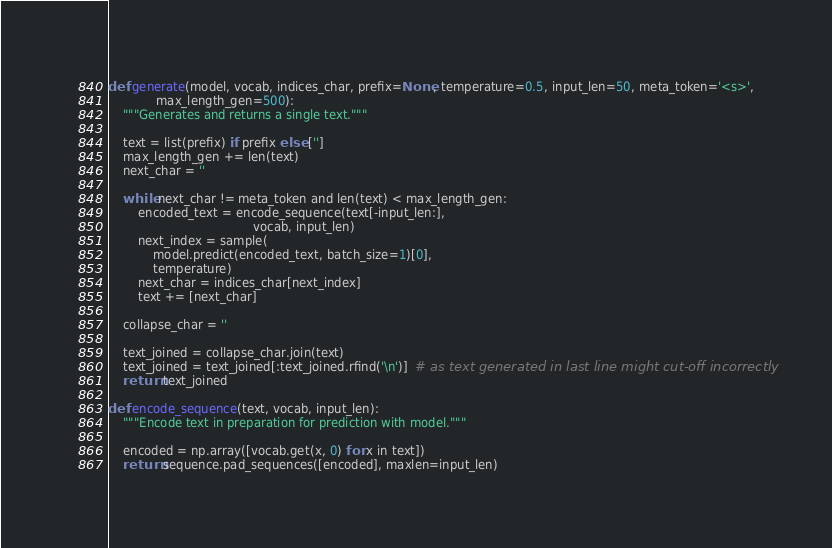Convert code to text. <code><loc_0><loc_0><loc_500><loc_500><_Python_>def generate(model, vocab, indices_char, prefix=None, temperature=0.5, input_len=50, meta_token='<s>',
             max_length_gen=500):
    """Generates and returns a single text."""

    text = list(prefix) if prefix else ['']
    max_length_gen += len(text)
    next_char = ''

    while next_char != meta_token and len(text) < max_length_gen:
        encoded_text = encode_sequence(text[-input_len:],
                                       vocab, input_len)
        next_index = sample(
            model.predict(encoded_text, batch_size=1)[0],
            temperature)
        next_char = indices_char[next_index]
        text += [next_char]

    collapse_char = ''

    text_joined = collapse_char.join(text)
    text_joined = text_joined[:text_joined.rfind('\n')]  # as text generated in last line might cut-off incorrectly
    return text_joined

def encode_sequence(text, vocab, input_len):
    """Encode text in preparation for prediction with model."""

    encoded = np.array([vocab.get(x, 0) for x in text])
    return sequence.pad_sequences([encoded], maxlen=input_len)
</code> 